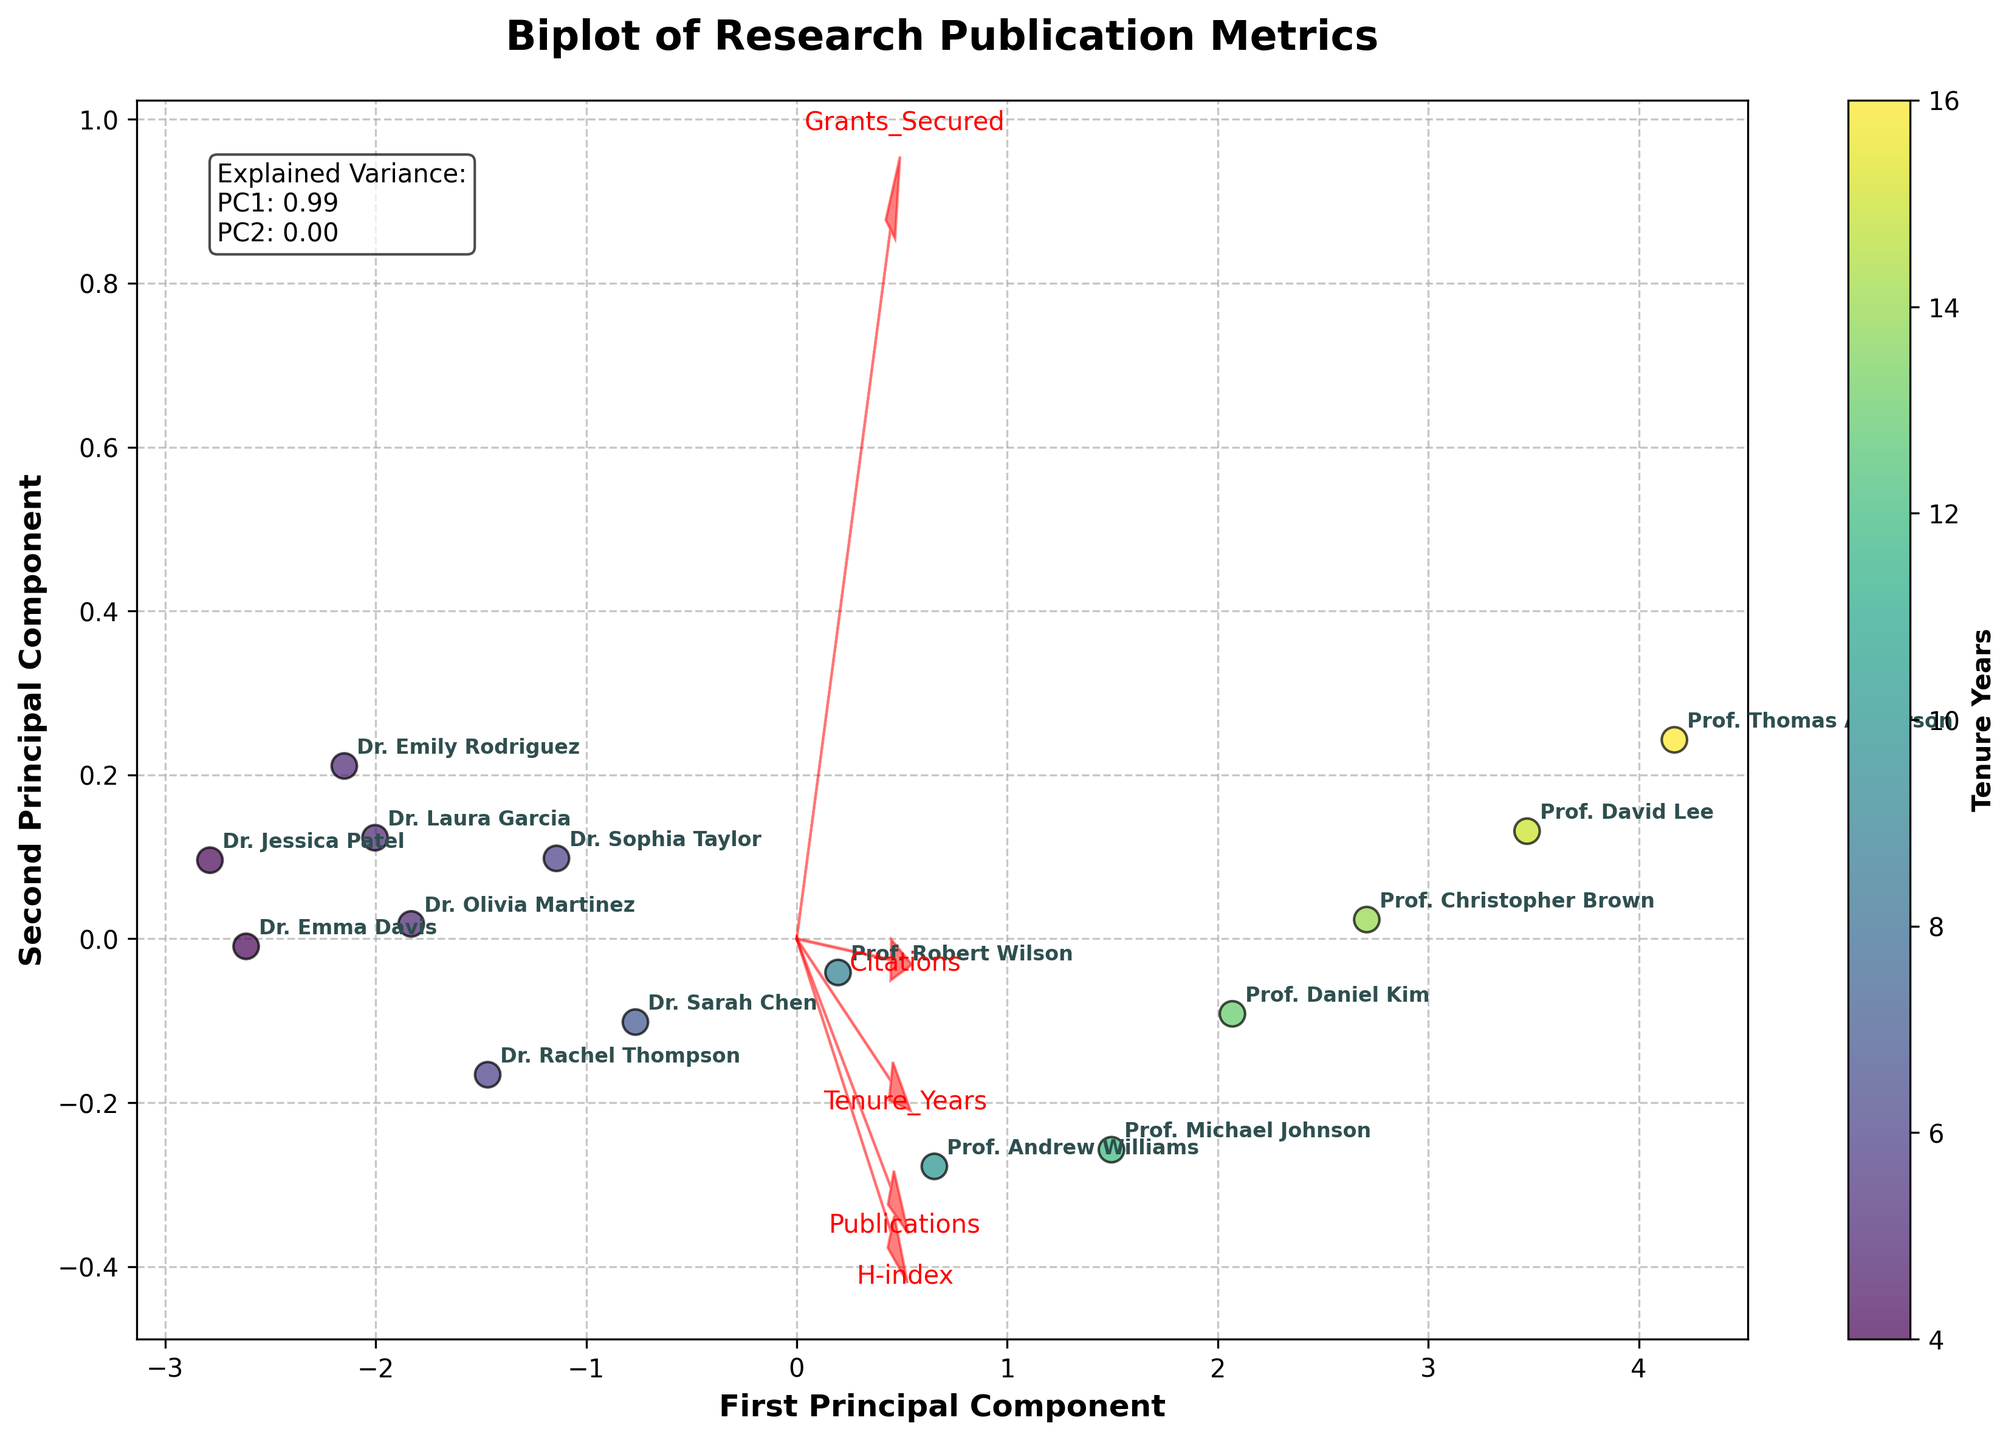What's the title of the figure? The title of the figure is located at the top and is clearly labeled in bold text. Simply read the title to identify it.
Answer: Biplot of Research Publication Metrics How many researchers are included in the figure? Count the number of unique annotations (names) in the plot to find the total number of researchers represented.
Answer: 15 Which feature is represented by the vector pointing most upwards in the biplot? Identify the vector with the highest y-component (pointing most upwards) among the plotted feature vectors.
Answer: Citations What's the color used in the figure to represent researchers with higher tenure years? Observe the color gradient in the colorbar on the right side of the plot. The color transitions from lighter to darker shades.
Answer: Darker shade What is the explained variance ratio for the first principal component (PC1)? Look for the text box in the figure that contains the explained variance ratio information. PC1's ratio is the first value listed.
Answer: 0.55 Which researcher has the highest value along the first principal component (PC1)? Examine the positions of researcher labels along the x-axis (PC1) and identify the one farthest to the right.
Answer: Prof. Thomas Anderson How do the H-index vector and the Publications vector compare in direction? Observe the direction of the arrows for the H-index and Publications. Comparing their angles and directions will show their relationship.
Answer: They are nearly aligned Are Tenure Years more correlated with Publications or Citations according to the biplot? Assess the alignment and proximity of the Tenure Years vector with the Publications and Citations vectors to determine which it is closer to and more aligned with.
Answer: Publications Which researcher is located closest to the origin in the biplot? Check for the researcher's position closest to the (0,0) coordinate in the plot area.
Answer: Dr. Jessica Patel Which feature has the smallest influence on the first principal component (PC1)? Determine which feature's vector is closest to being horizontal or has the smallest projection on the x-axis.
Answer: Grants_Secured 